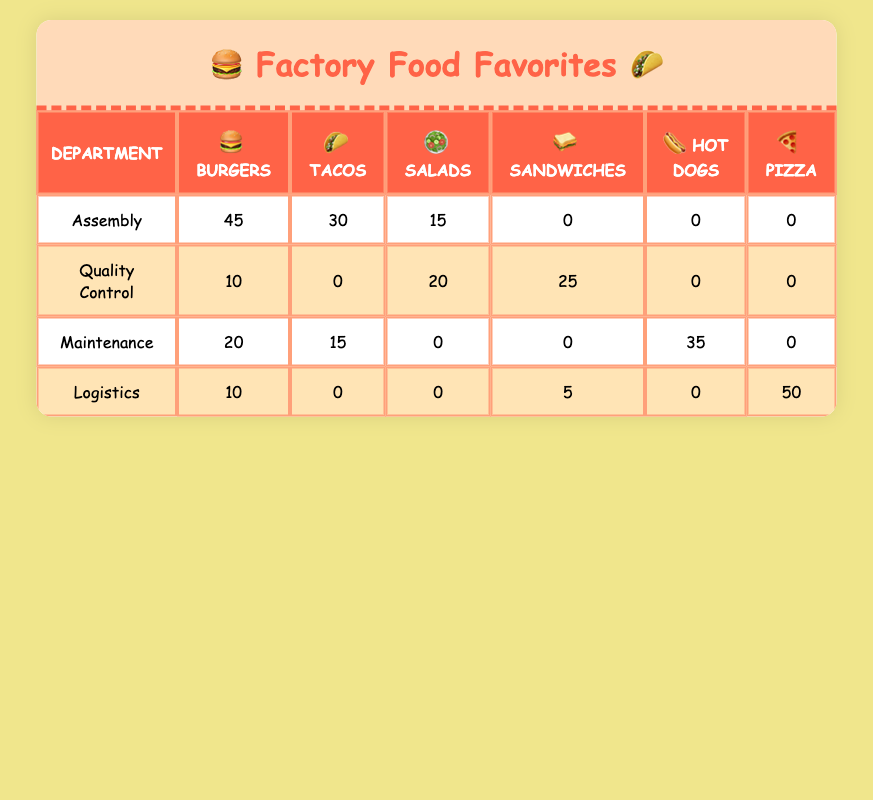What food preference is most popular in the Assembly department? The table shows that the count of burgers in the Assembly department is 45, which is higher than tacos (30) and salads (15). Therefore, burgers are the most popular food preference in this department.
Answer: Burgers How many total food preferences are recorded for the Quality Control department? The table lists three food preferences for the Quality Control department: salads (20), sandwiches (25), and burgers (10). Adding these counts gives 20 + 25 + 10 = 55.
Answer: 55 Are there any food preferences that have a count of zero in the Maintenance department? The table shows that in the Maintenance department, the food preferences of salads, sandwiches, and pizza have counts of zero. Therefore, there are indeed food preferences with a count of zero in this department.
Answer: Yes Which department has the highest count for Hot Dogs? The table indicates that only the Maintenance department has a count for Hot Dogs, which is 35. No other department shows a count for this food preference, making Maintenance the department with the highest count for Hot Dogs.
Answer: Maintenance What is the total count of Burgers across all departments? To find the total count of Burgers, add the counts from each department: Assembly (45), Quality Control (10), Maintenance (20), and Logistics (10). So, 45 + 10 + 20 + 10 = 95.
Answer: 95 What is the difference in the count of Tacos between the Assembly and Maintenance departments? In the Assembly department, the count of Tacos is 30, whereas in the Maintenance department it is 15. Calculating the difference: 30 - 15 = 15.
Answer: 15 Does the Logistics department have more counts in Pizza than in any other food preference? In the Logistics department, Pizza has a count of 50, while the counts for burgers and sandwiches are 10 and 5, respectively. Since 50 is greater than both 10 and 5, the Logistics department does have more counts in Pizza than in any other food preference.
Answer: Yes How many food preferences did the Quality Control department prefer over Burgers? The Quality Control department shows a preference for salads (20) and sandwiches (25) over burgers (10). Adding these together gives 20 + 25 = 45, exceeding the count for burgers in that department.
Answer: 45 Which food preference is least popular in the Logistics department? The table shows that within the Logistics department, the food preferences are Pizza (50), Burgers (10), and Sandwiches (5). The least popular food preference here is Sandwiches, with a count of 5.
Answer: Sandwiches 